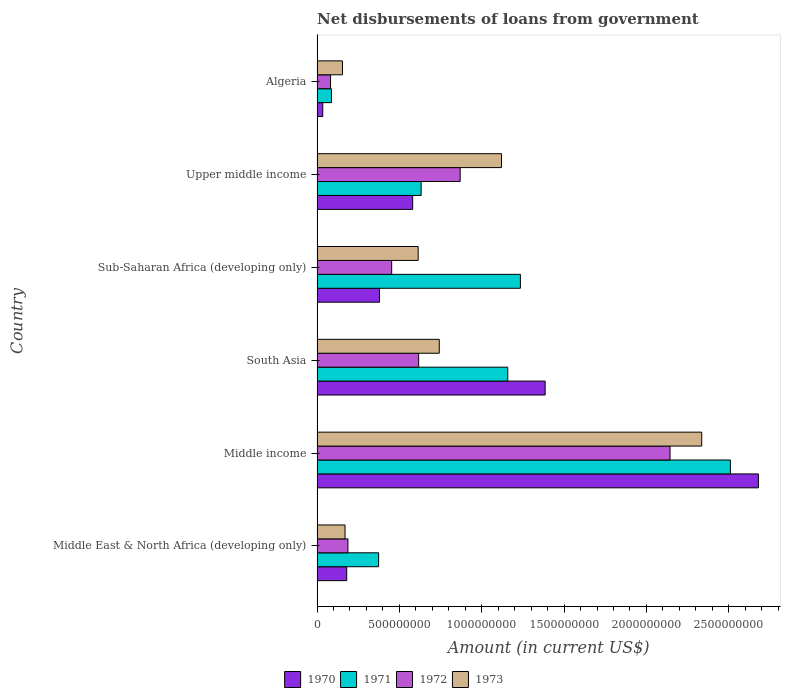How many different coloured bars are there?
Your response must be concise. 4. How many groups of bars are there?
Ensure brevity in your answer.  6. Are the number of bars on each tick of the Y-axis equal?
Your answer should be compact. Yes. How many bars are there on the 4th tick from the top?
Your response must be concise. 4. How many bars are there on the 1st tick from the bottom?
Give a very brief answer. 4. What is the label of the 2nd group of bars from the top?
Your answer should be very brief. Upper middle income. What is the amount of loan disbursed from government in 1973 in Sub-Saharan Africa (developing only)?
Offer a very short reply. 6.14e+08. Across all countries, what is the maximum amount of loan disbursed from government in 1973?
Provide a short and direct response. 2.34e+09. Across all countries, what is the minimum amount of loan disbursed from government in 1970?
Offer a terse response. 3.47e+07. In which country was the amount of loan disbursed from government in 1972 maximum?
Offer a very short reply. Middle income. In which country was the amount of loan disbursed from government in 1973 minimum?
Keep it short and to the point. Algeria. What is the total amount of loan disbursed from government in 1971 in the graph?
Your answer should be compact. 6.00e+09. What is the difference between the amount of loan disbursed from government in 1973 in Sub-Saharan Africa (developing only) and that in Upper middle income?
Offer a very short reply. -5.06e+08. What is the difference between the amount of loan disbursed from government in 1973 in South Asia and the amount of loan disbursed from government in 1970 in Middle East & North Africa (developing only)?
Offer a very short reply. 5.62e+08. What is the average amount of loan disbursed from government in 1973 per country?
Offer a terse response. 8.56e+08. What is the difference between the amount of loan disbursed from government in 1971 and amount of loan disbursed from government in 1970 in Algeria?
Keep it short and to the point. 5.27e+07. What is the ratio of the amount of loan disbursed from government in 1972 in Middle income to that in Sub-Saharan Africa (developing only)?
Make the answer very short. 4.73. Is the difference between the amount of loan disbursed from government in 1971 in Middle income and South Asia greater than the difference between the amount of loan disbursed from government in 1970 in Middle income and South Asia?
Provide a short and direct response. Yes. What is the difference between the highest and the second highest amount of loan disbursed from government in 1972?
Provide a succinct answer. 1.27e+09. What is the difference between the highest and the lowest amount of loan disbursed from government in 1970?
Your answer should be very brief. 2.65e+09. In how many countries, is the amount of loan disbursed from government in 1973 greater than the average amount of loan disbursed from government in 1973 taken over all countries?
Offer a terse response. 2. Is it the case that in every country, the sum of the amount of loan disbursed from government in 1973 and amount of loan disbursed from government in 1971 is greater than the sum of amount of loan disbursed from government in 1970 and amount of loan disbursed from government in 1972?
Provide a short and direct response. No. Is it the case that in every country, the sum of the amount of loan disbursed from government in 1972 and amount of loan disbursed from government in 1971 is greater than the amount of loan disbursed from government in 1973?
Your answer should be very brief. Yes. Are all the bars in the graph horizontal?
Provide a succinct answer. Yes. How many countries are there in the graph?
Offer a terse response. 6. What is the difference between two consecutive major ticks on the X-axis?
Provide a succinct answer. 5.00e+08. Where does the legend appear in the graph?
Give a very brief answer. Bottom center. How are the legend labels stacked?
Provide a short and direct response. Horizontal. What is the title of the graph?
Make the answer very short. Net disbursements of loans from government. What is the Amount (in current US$) of 1970 in Middle East & North Africa (developing only)?
Make the answer very short. 1.80e+08. What is the Amount (in current US$) in 1971 in Middle East & North Africa (developing only)?
Make the answer very short. 3.74e+08. What is the Amount (in current US$) of 1972 in Middle East & North Africa (developing only)?
Offer a terse response. 1.88e+08. What is the Amount (in current US$) of 1973 in Middle East & North Africa (developing only)?
Your answer should be compact. 1.70e+08. What is the Amount (in current US$) in 1970 in Middle income?
Your answer should be compact. 2.68e+09. What is the Amount (in current US$) of 1971 in Middle income?
Your answer should be very brief. 2.51e+09. What is the Amount (in current US$) in 1972 in Middle income?
Your answer should be very brief. 2.14e+09. What is the Amount (in current US$) in 1973 in Middle income?
Provide a succinct answer. 2.34e+09. What is the Amount (in current US$) of 1970 in South Asia?
Give a very brief answer. 1.39e+09. What is the Amount (in current US$) of 1971 in South Asia?
Your response must be concise. 1.16e+09. What is the Amount (in current US$) in 1972 in South Asia?
Your response must be concise. 6.17e+08. What is the Amount (in current US$) of 1973 in South Asia?
Provide a short and direct response. 7.42e+08. What is the Amount (in current US$) of 1970 in Sub-Saharan Africa (developing only)?
Provide a short and direct response. 3.79e+08. What is the Amount (in current US$) in 1971 in Sub-Saharan Africa (developing only)?
Provide a succinct answer. 1.23e+09. What is the Amount (in current US$) in 1972 in Sub-Saharan Africa (developing only)?
Make the answer very short. 4.53e+08. What is the Amount (in current US$) in 1973 in Sub-Saharan Africa (developing only)?
Provide a short and direct response. 6.14e+08. What is the Amount (in current US$) of 1970 in Upper middle income?
Make the answer very short. 5.81e+08. What is the Amount (in current US$) in 1971 in Upper middle income?
Your response must be concise. 6.32e+08. What is the Amount (in current US$) in 1972 in Upper middle income?
Keep it short and to the point. 8.69e+08. What is the Amount (in current US$) in 1973 in Upper middle income?
Provide a succinct answer. 1.12e+09. What is the Amount (in current US$) in 1970 in Algeria?
Provide a succinct answer. 3.47e+07. What is the Amount (in current US$) in 1971 in Algeria?
Ensure brevity in your answer.  8.74e+07. What is the Amount (in current US$) in 1972 in Algeria?
Your answer should be compact. 8.20e+07. What is the Amount (in current US$) in 1973 in Algeria?
Provide a succinct answer. 1.54e+08. Across all countries, what is the maximum Amount (in current US$) of 1970?
Offer a terse response. 2.68e+09. Across all countries, what is the maximum Amount (in current US$) in 1971?
Offer a terse response. 2.51e+09. Across all countries, what is the maximum Amount (in current US$) in 1972?
Offer a very short reply. 2.14e+09. Across all countries, what is the maximum Amount (in current US$) of 1973?
Your answer should be compact. 2.34e+09. Across all countries, what is the minimum Amount (in current US$) in 1970?
Provide a succinct answer. 3.47e+07. Across all countries, what is the minimum Amount (in current US$) in 1971?
Ensure brevity in your answer.  8.74e+07. Across all countries, what is the minimum Amount (in current US$) in 1972?
Offer a terse response. 8.20e+07. Across all countries, what is the minimum Amount (in current US$) in 1973?
Provide a short and direct response. 1.54e+08. What is the total Amount (in current US$) in 1970 in the graph?
Your answer should be compact. 5.24e+09. What is the total Amount (in current US$) in 1971 in the graph?
Give a very brief answer. 6.00e+09. What is the total Amount (in current US$) in 1972 in the graph?
Keep it short and to the point. 4.35e+09. What is the total Amount (in current US$) in 1973 in the graph?
Provide a succinct answer. 5.14e+09. What is the difference between the Amount (in current US$) in 1970 in Middle East & North Africa (developing only) and that in Middle income?
Offer a terse response. -2.50e+09. What is the difference between the Amount (in current US$) of 1971 in Middle East & North Africa (developing only) and that in Middle income?
Your answer should be compact. -2.14e+09. What is the difference between the Amount (in current US$) of 1972 in Middle East & North Africa (developing only) and that in Middle income?
Offer a terse response. -1.96e+09. What is the difference between the Amount (in current US$) of 1973 in Middle East & North Africa (developing only) and that in Middle income?
Ensure brevity in your answer.  -2.17e+09. What is the difference between the Amount (in current US$) of 1970 in Middle East & North Africa (developing only) and that in South Asia?
Provide a succinct answer. -1.20e+09. What is the difference between the Amount (in current US$) in 1971 in Middle East & North Africa (developing only) and that in South Asia?
Ensure brevity in your answer.  -7.84e+08. What is the difference between the Amount (in current US$) in 1972 in Middle East & North Africa (developing only) and that in South Asia?
Ensure brevity in your answer.  -4.29e+08. What is the difference between the Amount (in current US$) of 1973 in Middle East & North Africa (developing only) and that in South Asia?
Your response must be concise. -5.72e+08. What is the difference between the Amount (in current US$) of 1970 in Middle East & North Africa (developing only) and that in Sub-Saharan Africa (developing only)?
Provide a succinct answer. -1.99e+08. What is the difference between the Amount (in current US$) in 1971 in Middle East & North Africa (developing only) and that in Sub-Saharan Africa (developing only)?
Keep it short and to the point. -8.61e+08. What is the difference between the Amount (in current US$) in 1972 in Middle East & North Africa (developing only) and that in Sub-Saharan Africa (developing only)?
Your answer should be compact. -2.66e+08. What is the difference between the Amount (in current US$) in 1973 in Middle East & North Africa (developing only) and that in Sub-Saharan Africa (developing only)?
Offer a very short reply. -4.44e+08. What is the difference between the Amount (in current US$) of 1970 in Middle East & North Africa (developing only) and that in Upper middle income?
Ensure brevity in your answer.  -4.01e+08. What is the difference between the Amount (in current US$) in 1971 in Middle East & North Africa (developing only) and that in Upper middle income?
Ensure brevity in your answer.  -2.58e+08. What is the difference between the Amount (in current US$) in 1972 in Middle East & North Africa (developing only) and that in Upper middle income?
Ensure brevity in your answer.  -6.81e+08. What is the difference between the Amount (in current US$) in 1973 in Middle East & North Africa (developing only) and that in Upper middle income?
Provide a short and direct response. -9.50e+08. What is the difference between the Amount (in current US$) in 1970 in Middle East & North Africa (developing only) and that in Algeria?
Your answer should be very brief. 1.45e+08. What is the difference between the Amount (in current US$) in 1971 in Middle East & North Africa (developing only) and that in Algeria?
Make the answer very short. 2.87e+08. What is the difference between the Amount (in current US$) in 1972 in Middle East & North Africa (developing only) and that in Algeria?
Give a very brief answer. 1.06e+08. What is the difference between the Amount (in current US$) of 1973 in Middle East & North Africa (developing only) and that in Algeria?
Keep it short and to the point. 1.56e+07. What is the difference between the Amount (in current US$) in 1970 in Middle income and that in South Asia?
Offer a very short reply. 1.30e+09. What is the difference between the Amount (in current US$) of 1971 in Middle income and that in South Asia?
Offer a terse response. 1.35e+09. What is the difference between the Amount (in current US$) of 1972 in Middle income and that in South Asia?
Make the answer very short. 1.53e+09. What is the difference between the Amount (in current US$) of 1973 in Middle income and that in South Asia?
Keep it short and to the point. 1.59e+09. What is the difference between the Amount (in current US$) of 1970 in Middle income and that in Sub-Saharan Africa (developing only)?
Offer a very short reply. 2.30e+09. What is the difference between the Amount (in current US$) in 1971 in Middle income and that in Sub-Saharan Africa (developing only)?
Give a very brief answer. 1.28e+09. What is the difference between the Amount (in current US$) in 1972 in Middle income and that in Sub-Saharan Africa (developing only)?
Offer a terse response. 1.69e+09. What is the difference between the Amount (in current US$) in 1973 in Middle income and that in Sub-Saharan Africa (developing only)?
Your answer should be compact. 1.72e+09. What is the difference between the Amount (in current US$) of 1970 in Middle income and that in Upper middle income?
Ensure brevity in your answer.  2.10e+09. What is the difference between the Amount (in current US$) in 1971 in Middle income and that in Upper middle income?
Offer a terse response. 1.88e+09. What is the difference between the Amount (in current US$) in 1972 in Middle income and that in Upper middle income?
Your response must be concise. 1.27e+09. What is the difference between the Amount (in current US$) of 1973 in Middle income and that in Upper middle income?
Your answer should be compact. 1.22e+09. What is the difference between the Amount (in current US$) in 1970 in Middle income and that in Algeria?
Provide a short and direct response. 2.65e+09. What is the difference between the Amount (in current US$) in 1971 in Middle income and that in Algeria?
Provide a short and direct response. 2.42e+09. What is the difference between the Amount (in current US$) of 1972 in Middle income and that in Algeria?
Give a very brief answer. 2.06e+09. What is the difference between the Amount (in current US$) in 1973 in Middle income and that in Algeria?
Keep it short and to the point. 2.18e+09. What is the difference between the Amount (in current US$) in 1970 in South Asia and that in Sub-Saharan Africa (developing only)?
Your response must be concise. 1.01e+09. What is the difference between the Amount (in current US$) in 1971 in South Asia and that in Sub-Saharan Africa (developing only)?
Offer a very short reply. -7.68e+07. What is the difference between the Amount (in current US$) in 1972 in South Asia and that in Sub-Saharan Africa (developing only)?
Keep it short and to the point. 1.64e+08. What is the difference between the Amount (in current US$) in 1973 in South Asia and that in Sub-Saharan Africa (developing only)?
Your answer should be compact. 1.28e+08. What is the difference between the Amount (in current US$) of 1970 in South Asia and that in Upper middle income?
Your response must be concise. 8.04e+08. What is the difference between the Amount (in current US$) in 1971 in South Asia and that in Upper middle income?
Ensure brevity in your answer.  5.26e+08. What is the difference between the Amount (in current US$) in 1972 in South Asia and that in Upper middle income?
Give a very brief answer. -2.52e+08. What is the difference between the Amount (in current US$) in 1973 in South Asia and that in Upper middle income?
Your response must be concise. -3.78e+08. What is the difference between the Amount (in current US$) in 1970 in South Asia and that in Algeria?
Your response must be concise. 1.35e+09. What is the difference between the Amount (in current US$) of 1971 in South Asia and that in Algeria?
Your answer should be compact. 1.07e+09. What is the difference between the Amount (in current US$) of 1972 in South Asia and that in Algeria?
Make the answer very short. 5.35e+08. What is the difference between the Amount (in current US$) in 1973 in South Asia and that in Algeria?
Ensure brevity in your answer.  5.88e+08. What is the difference between the Amount (in current US$) in 1970 in Sub-Saharan Africa (developing only) and that in Upper middle income?
Offer a very short reply. -2.01e+08. What is the difference between the Amount (in current US$) in 1971 in Sub-Saharan Africa (developing only) and that in Upper middle income?
Your response must be concise. 6.03e+08. What is the difference between the Amount (in current US$) of 1972 in Sub-Saharan Africa (developing only) and that in Upper middle income?
Provide a succinct answer. -4.16e+08. What is the difference between the Amount (in current US$) in 1973 in Sub-Saharan Africa (developing only) and that in Upper middle income?
Your answer should be very brief. -5.06e+08. What is the difference between the Amount (in current US$) of 1970 in Sub-Saharan Africa (developing only) and that in Algeria?
Keep it short and to the point. 3.44e+08. What is the difference between the Amount (in current US$) of 1971 in Sub-Saharan Africa (developing only) and that in Algeria?
Ensure brevity in your answer.  1.15e+09. What is the difference between the Amount (in current US$) of 1972 in Sub-Saharan Africa (developing only) and that in Algeria?
Give a very brief answer. 3.71e+08. What is the difference between the Amount (in current US$) in 1973 in Sub-Saharan Africa (developing only) and that in Algeria?
Make the answer very short. 4.60e+08. What is the difference between the Amount (in current US$) of 1970 in Upper middle income and that in Algeria?
Ensure brevity in your answer.  5.46e+08. What is the difference between the Amount (in current US$) of 1971 in Upper middle income and that in Algeria?
Your response must be concise. 5.45e+08. What is the difference between the Amount (in current US$) in 1972 in Upper middle income and that in Algeria?
Offer a very short reply. 7.87e+08. What is the difference between the Amount (in current US$) in 1973 in Upper middle income and that in Algeria?
Keep it short and to the point. 9.66e+08. What is the difference between the Amount (in current US$) of 1970 in Middle East & North Africa (developing only) and the Amount (in current US$) of 1971 in Middle income?
Provide a succinct answer. -2.33e+09. What is the difference between the Amount (in current US$) of 1970 in Middle East & North Africa (developing only) and the Amount (in current US$) of 1972 in Middle income?
Provide a succinct answer. -1.96e+09. What is the difference between the Amount (in current US$) in 1970 in Middle East & North Africa (developing only) and the Amount (in current US$) in 1973 in Middle income?
Your answer should be compact. -2.16e+09. What is the difference between the Amount (in current US$) of 1971 in Middle East & North Africa (developing only) and the Amount (in current US$) of 1972 in Middle income?
Give a very brief answer. -1.77e+09. What is the difference between the Amount (in current US$) in 1971 in Middle East & North Africa (developing only) and the Amount (in current US$) in 1973 in Middle income?
Keep it short and to the point. -1.96e+09. What is the difference between the Amount (in current US$) of 1972 in Middle East & North Africa (developing only) and the Amount (in current US$) of 1973 in Middle income?
Provide a short and direct response. -2.15e+09. What is the difference between the Amount (in current US$) of 1970 in Middle East & North Africa (developing only) and the Amount (in current US$) of 1971 in South Asia?
Your answer should be compact. -9.78e+08. What is the difference between the Amount (in current US$) in 1970 in Middle East & North Africa (developing only) and the Amount (in current US$) in 1972 in South Asia?
Your answer should be very brief. -4.37e+08. What is the difference between the Amount (in current US$) in 1970 in Middle East & North Africa (developing only) and the Amount (in current US$) in 1973 in South Asia?
Provide a succinct answer. -5.62e+08. What is the difference between the Amount (in current US$) of 1971 in Middle East & North Africa (developing only) and the Amount (in current US$) of 1972 in South Asia?
Provide a succinct answer. -2.43e+08. What is the difference between the Amount (in current US$) of 1971 in Middle East & North Africa (developing only) and the Amount (in current US$) of 1973 in South Asia?
Your response must be concise. -3.68e+08. What is the difference between the Amount (in current US$) in 1972 in Middle East & North Africa (developing only) and the Amount (in current US$) in 1973 in South Asia?
Your response must be concise. -5.55e+08. What is the difference between the Amount (in current US$) in 1970 in Middle East & North Africa (developing only) and the Amount (in current US$) in 1971 in Sub-Saharan Africa (developing only)?
Your answer should be very brief. -1.05e+09. What is the difference between the Amount (in current US$) in 1970 in Middle East & North Africa (developing only) and the Amount (in current US$) in 1972 in Sub-Saharan Africa (developing only)?
Your answer should be compact. -2.73e+08. What is the difference between the Amount (in current US$) in 1970 in Middle East & North Africa (developing only) and the Amount (in current US$) in 1973 in Sub-Saharan Africa (developing only)?
Offer a very short reply. -4.34e+08. What is the difference between the Amount (in current US$) of 1971 in Middle East & North Africa (developing only) and the Amount (in current US$) of 1972 in Sub-Saharan Africa (developing only)?
Provide a short and direct response. -7.92e+07. What is the difference between the Amount (in current US$) of 1971 in Middle East & North Africa (developing only) and the Amount (in current US$) of 1973 in Sub-Saharan Africa (developing only)?
Your answer should be compact. -2.40e+08. What is the difference between the Amount (in current US$) of 1972 in Middle East & North Africa (developing only) and the Amount (in current US$) of 1973 in Sub-Saharan Africa (developing only)?
Your response must be concise. -4.27e+08. What is the difference between the Amount (in current US$) of 1970 in Middle East & North Africa (developing only) and the Amount (in current US$) of 1971 in Upper middle income?
Your answer should be compact. -4.52e+08. What is the difference between the Amount (in current US$) in 1970 in Middle East & North Africa (developing only) and the Amount (in current US$) in 1972 in Upper middle income?
Your answer should be very brief. -6.89e+08. What is the difference between the Amount (in current US$) of 1970 in Middle East & North Africa (developing only) and the Amount (in current US$) of 1973 in Upper middle income?
Provide a succinct answer. -9.40e+08. What is the difference between the Amount (in current US$) in 1971 in Middle East & North Africa (developing only) and the Amount (in current US$) in 1972 in Upper middle income?
Your answer should be very brief. -4.95e+08. What is the difference between the Amount (in current US$) in 1971 in Middle East & North Africa (developing only) and the Amount (in current US$) in 1973 in Upper middle income?
Ensure brevity in your answer.  -7.46e+08. What is the difference between the Amount (in current US$) of 1972 in Middle East & North Africa (developing only) and the Amount (in current US$) of 1973 in Upper middle income?
Give a very brief answer. -9.32e+08. What is the difference between the Amount (in current US$) in 1970 in Middle East & North Africa (developing only) and the Amount (in current US$) in 1971 in Algeria?
Your answer should be very brief. 9.27e+07. What is the difference between the Amount (in current US$) of 1970 in Middle East & North Africa (developing only) and the Amount (in current US$) of 1972 in Algeria?
Give a very brief answer. 9.81e+07. What is the difference between the Amount (in current US$) in 1970 in Middle East & North Africa (developing only) and the Amount (in current US$) in 1973 in Algeria?
Make the answer very short. 2.58e+07. What is the difference between the Amount (in current US$) in 1971 in Middle East & North Africa (developing only) and the Amount (in current US$) in 1972 in Algeria?
Make the answer very short. 2.92e+08. What is the difference between the Amount (in current US$) of 1971 in Middle East & North Africa (developing only) and the Amount (in current US$) of 1973 in Algeria?
Provide a short and direct response. 2.20e+08. What is the difference between the Amount (in current US$) of 1972 in Middle East & North Africa (developing only) and the Amount (in current US$) of 1973 in Algeria?
Provide a succinct answer. 3.33e+07. What is the difference between the Amount (in current US$) of 1970 in Middle income and the Amount (in current US$) of 1971 in South Asia?
Offer a very short reply. 1.52e+09. What is the difference between the Amount (in current US$) in 1970 in Middle income and the Amount (in current US$) in 1972 in South Asia?
Provide a short and direct response. 2.06e+09. What is the difference between the Amount (in current US$) in 1970 in Middle income and the Amount (in current US$) in 1973 in South Asia?
Ensure brevity in your answer.  1.94e+09. What is the difference between the Amount (in current US$) of 1971 in Middle income and the Amount (in current US$) of 1972 in South Asia?
Ensure brevity in your answer.  1.89e+09. What is the difference between the Amount (in current US$) of 1971 in Middle income and the Amount (in current US$) of 1973 in South Asia?
Your answer should be very brief. 1.77e+09. What is the difference between the Amount (in current US$) in 1972 in Middle income and the Amount (in current US$) in 1973 in South Asia?
Make the answer very short. 1.40e+09. What is the difference between the Amount (in current US$) in 1970 in Middle income and the Amount (in current US$) in 1971 in Sub-Saharan Africa (developing only)?
Keep it short and to the point. 1.45e+09. What is the difference between the Amount (in current US$) in 1970 in Middle income and the Amount (in current US$) in 1972 in Sub-Saharan Africa (developing only)?
Your answer should be compact. 2.23e+09. What is the difference between the Amount (in current US$) of 1970 in Middle income and the Amount (in current US$) of 1973 in Sub-Saharan Africa (developing only)?
Offer a terse response. 2.07e+09. What is the difference between the Amount (in current US$) of 1971 in Middle income and the Amount (in current US$) of 1972 in Sub-Saharan Africa (developing only)?
Provide a succinct answer. 2.06e+09. What is the difference between the Amount (in current US$) of 1971 in Middle income and the Amount (in current US$) of 1973 in Sub-Saharan Africa (developing only)?
Offer a very short reply. 1.90e+09. What is the difference between the Amount (in current US$) in 1972 in Middle income and the Amount (in current US$) in 1973 in Sub-Saharan Africa (developing only)?
Keep it short and to the point. 1.53e+09. What is the difference between the Amount (in current US$) of 1970 in Middle income and the Amount (in current US$) of 1971 in Upper middle income?
Your answer should be very brief. 2.05e+09. What is the difference between the Amount (in current US$) in 1970 in Middle income and the Amount (in current US$) in 1972 in Upper middle income?
Offer a very short reply. 1.81e+09. What is the difference between the Amount (in current US$) in 1970 in Middle income and the Amount (in current US$) in 1973 in Upper middle income?
Offer a very short reply. 1.56e+09. What is the difference between the Amount (in current US$) in 1971 in Middle income and the Amount (in current US$) in 1972 in Upper middle income?
Make the answer very short. 1.64e+09. What is the difference between the Amount (in current US$) of 1971 in Middle income and the Amount (in current US$) of 1973 in Upper middle income?
Ensure brevity in your answer.  1.39e+09. What is the difference between the Amount (in current US$) in 1972 in Middle income and the Amount (in current US$) in 1973 in Upper middle income?
Give a very brief answer. 1.02e+09. What is the difference between the Amount (in current US$) in 1970 in Middle income and the Amount (in current US$) in 1971 in Algeria?
Provide a succinct answer. 2.59e+09. What is the difference between the Amount (in current US$) of 1970 in Middle income and the Amount (in current US$) of 1972 in Algeria?
Your answer should be compact. 2.60e+09. What is the difference between the Amount (in current US$) of 1970 in Middle income and the Amount (in current US$) of 1973 in Algeria?
Your response must be concise. 2.53e+09. What is the difference between the Amount (in current US$) in 1971 in Middle income and the Amount (in current US$) in 1972 in Algeria?
Offer a terse response. 2.43e+09. What is the difference between the Amount (in current US$) in 1971 in Middle income and the Amount (in current US$) in 1973 in Algeria?
Give a very brief answer. 2.36e+09. What is the difference between the Amount (in current US$) of 1972 in Middle income and the Amount (in current US$) of 1973 in Algeria?
Your response must be concise. 1.99e+09. What is the difference between the Amount (in current US$) of 1970 in South Asia and the Amount (in current US$) of 1971 in Sub-Saharan Africa (developing only)?
Keep it short and to the point. 1.50e+08. What is the difference between the Amount (in current US$) in 1970 in South Asia and the Amount (in current US$) in 1972 in Sub-Saharan Africa (developing only)?
Ensure brevity in your answer.  9.32e+08. What is the difference between the Amount (in current US$) of 1970 in South Asia and the Amount (in current US$) of 1973 in Sub-Saharan Africa (developing only)?
Make the answer very short. 7.71e+08. What is the difference between the Amount (in current US$) of 1971 in South Asia and the Amount (in current US$) of 1972 in Sub-Saharan Africa (developing only)?
Give a very brief answer. 7.05e+08. What is the difference between the Amount (in current US$) of 1971 in South Asia and the Amount (in current US$) of 1973 in Sub-Saharan Africa (developing only)?
Offer a terse response. 5.44e+08. What is the difference between the Amount (in current US$) in 1972 in South Asia and the Amount (in current US$) in 1973 in Sub-Saharan Africa (developing only)?
Provide a short and direct response. 2.74e+06. What is the difference between the Amount (in current US$) in 1970 in South Asia and the Amount (in current US$) in 1971 in Upper middle income?
Provide a succinct answer. 7.53e+08. What is the difference between the Amount (in current US$) in 1970 in South Asia and the Amount (in current US$) in 1972 in Upper middle income?
Your answer should be very brief. 5.16e+08. What is the difference between the Amount (in current US$) in 1970 in South Asia and the Amount (in current US$) in 1973 in Upper middle income?
Offer a very short reply. 2.65e+08. What is the difference between the Amount (in current US$) in 1971 in South Asia and the Amount (in current US$) in 1972 in Upper middle income?
Give a very brief answer. 2.89e+08. What is the difference between the Amount (in current US$) of 1971 in South Asia and the Amount (in current US$) of 1973 in Upper middle income?
Your response must be concise. 3.80e+07. What is the difference between the Amount (in current US$) of 1972 in South Asia and the Amount (in current US$) of 1973 in Upper middle income?
Offer a very short reply. -5.03e+08. What is the difference between the Amount (in current US$) in 1970 in South Asia and the Amount (in current US$) in 1971 in Algeria?
Make the answer very short. 1.30e+09. What is the difference between the Amount (in current US$) of 1970 in South Asia and the Amount (in current US$) of 1972 in Algeria?
Keep it short and to the point. 1.30e+09. What is the difference between the Amount (in current US$) in 1970 in South Asia and the Amount (in current US$) in 1973 in Algeria?
Your response must be concise. 1.23e+09. What is the difference between the Amount (in current US$) of 1971 in South Asia and the Amount (in current US$) of 1972 in Algeria?
Provide a succinct answer. 1.08e+09. What is the difference between the Amount (in current US$) of 1971 in South Asia and the Amount (in current US$) of 1973 in Algeria?
Offer a terse response. 1.00e+09. What is the difference between the Amount (in current US$) of 1972 in South Asia and the Amount (in current US$) of 1973 in Algeria?
Your response must be concise. 4.63e+08. What is the difference between the Amount (in current US$) of 1970 in Sub-Saharan Africa (developing only) and the Amount (in current US$) of 1971 in Upper middle income?
Make the answer very short. -2.53e+08. What is the difference between the Amount (in current US$) of 1970 in Sub-Saharan Africa (developing only) and the Amount (in current US$) of 1972 in Upper middle income?
Provide a short and direct response. -4.90e+08. What is the difference between the Amount (in current US$) of 1970 in Sub-Saharan Africa (developing only) and the Amount (in current US$) of 1973 in Upper middle income?
Keep it short and to the point. -7.41e+08. What is the difference between the Amount (in current US$) in 1971 in Sub-Saharan Africa (developing only) and the Amount (in current US$) in 1972 in Upper middle income?
Give a very brief answer. 3.66e+08. What is the difference between the Amount (in current US$) of 1971 in Sub-Saharan Africa (developing only) and the Amount (in current US$) of 1973 in Upper middle income?
Make the answer very short. 1.15e+08. What is the difference between the Amount (in current US$) of 1972 in Sub-Saharan Africa (developing only) and the Amount (in current US$) of 1973 in Upper middle income?
Give a very brief answer. -6.67e+08. What is the difference between the Amount (in current US$) in 1970 in Sub-Saharan Africa (developing only) and the Amount (in current US$) in 1971 in Algeria?
Make the answer very short. 2.92e+08. What is the difference between the Amount (in current US$) of 1970 in Sub-Saharan Africa (developing only) and the Amount (in current US$) of 1972 in Algeria?
Your answer should be very brief. 2.97e+08. What is the difference between the Amount (in current US$) of 1970 in Sub-Saharan Africa (developing only) and the Amount (in current US$) of 1973 in Algeria?
Provide a short and direct response. 2.25e+08. What is the difference between the Amount (in current US$) in 1971 in Sub-Saharan Africa (developing only) and the Amount (in current US$) in 1972 in Algeria?
Make the answer very short. 1.15e+09. What is the difference between the Amount (in current US$) of 1971 in Sub-Saharan Africa (developing only) and the Amount (in current US$) of 1973 in Algeria?
Give a very brief answer. 1.08e+09. What is the difference between the Amount (in current US$) in 1972 in Sub-Saharan Africa (developing only) and the Amount (in current US$) in 1973 in Algeria?
Offer a very short reply. 2.99e+08. What is the difference between the Amount (in current US$) in 1970 in Upper middle income and the Amount (in current US$) in 1971 in Algeria?
Your response must be concise. 4.93e+08. What is the difference between the Amount (in current US$) in 1970 in Upper middle income and the Amount (in current US$) in 1972 in Algeria?
Your response must be concise. 4.99e+08. What is the difference between the Amount (in current US$) of 1970 in Upper middle income and the Amount (in current US$) of 1973 in Algeria?
Your answer should be compact. 4.26e+08. What is the difference between the Amount (in current US$) of 1971 in Upper middle income and the Amount (in current US$) of 1972 in Algeria?
Your answer should be very brief. 5.50e+08. What is the difference between the Amount (in current US$) of 1971 in Upper middle income and the Amount (in current US$) of 1973 in Algeria?
Provide a succinct answer. 4.78e+08. What is the difference between the Amount (in current US$) of 1972 in Upper middle income and the Amount (in current US$) of 1973 in Algeria?
Provide a succinct answer. 7.15e+08. What is the average Amount (in current US$) in 1970 per country?
Ensure brevity in your answer.  8.73e+08. What is the average Amount (in current US$) of 1971 per country?
Provide a succinct answer. 9.99e+08. What is the average Amount (in current US$) in 1972 per country?
Ensure brevity in your answer.  7.25e+08. What is the average Amount (in current US$) in 1973 per country?
Keep it short and to the point. 8.56e+08. What is the difference between the Amount (in current US$) of 1970 and Amount (in current US$) of 1971 in Middle East & North Africa (developing only)?
Your answer should be compact. -1.94e+08. What is the difference between the Amount (in current US$) of 1970 and Amount (in current US$) of 1972 in Middle East & North Africa (developing only)?
Your response must be concise. -7.47e+06. What is the difference between the Amount (in current US$) in 1970 and Amount (in current US$) in 1973 in Middle East & North Africa (developing only)?
Your response must be concise. 1.02e+07. What is the difference between the Amount (in current US$) of 1971 and Amount (in current US$) of 1972 in Middle East & North Africa (developing only)?
Offer a terse response. 1.86e+08. What is the difference between the Amount (in current US$) of 1971 and Amount (in current US$) of 1973 in Middle East & North Africa (developing only)?
Your response must be concise. 2.04e+08. What is the difference between the Amount (in current US$) of 1972 and Amount (in current US$) of 1973 in Middle East & North Africa (developing only)?
Your answer should be compact. 1.77e+07. What is the difference between the Amount (in current US$) of 1970 and Amount (in current US$) of 1971 in Middle income?
Give a very brief answer. 1.70e+08. What is the difference between the Amount (in current US$) of 1970 and Amount (in current US$) of 1972 in Middle income?
Offer a very short reply. 5.37e+08. What is the difference between the Amount (in current US$) in 1970 and Amount (in current US$) in 1973 in Middle income?
Give a very brief answer. 3.44e+08. What is the difference between the Amount (in current US$) of 1971 and Amount (in current US$) of 1972 in Middle income?
Keep it short and to the point. 3.67e+08. What is the difference between the Amount (in current US$) of 1971 and Amount (in current US$) of 1973 in Middle income?
Give a very brief answer. 1.74e+08. What is the difference between the Amount (in current US$) in 1972 and Amount (in current US$) in 1973 in Middle income?
Your answer should be very brief. -1.92e+08. What is the difference between the Amount (in current US$) in 1970 and Amount (in current US$) in 1971 in South Asia?
Your answer should be compact. 2.27e+08. What is the difference between the Amount (in current US$) in 1970 and Amount (in current US$) in 1972 in South Asia?
Provide a succinct answer. 7.68e+08. What is the difference between the Amount (in current US$) in 1970 and Amount (in current US$) in 1973 in South Asia?
Provide a succinct answer. 6.43e+08. What is the difference between the Amount (in current US$) of 1971 and Amount (in current US$) of 1972 in South Asia?
Make the answer very short. 5.41e+08. What is the difference between the Amount (in current US$) of 1971 and Amount (in current US$) of 1973 in South Asia?
Your answer should be compact. 4.16e+08. What is the difference between the Amount (in current US$) of 1972 and Amount (in current US$) of 1973 in South Asia?
Provide a short and direct response. -1.25e+08. What is the difference between the Amount (in current US$) of 1970 and Amount (in current US$) of 1971 in Sub-Saharan Africa (developing only)?
Provide a short and direct response. -8.56e+08. What is the difference between the Amount (in current US$) in 1970 and Amount (in current US$) in 1972 in Sub-Saharan Africa (developing only)?
Your answer should be compact. -7.40e+07. What is the difference between the Amount (in current US$) in 1970 and Amount (in current US$) in 1973 in Sub-Saharan Africa (developing only)?
Offer a very short reply. -2.35e+08. What is the difference between the Amount (in current US$) of 1971 and Amount (in current US$) of 1972 in Sub-Saharan Africa (developing only)?
Ensure brevity in your answer.  7.82e+08. What is the difference between the Amount (in current US$) of 1971 and Amount (in current US$) of 1973 in Sub-Saharan Africa (developing only)?
Offer a very short reply. 6.21e+08. What is the difference between the Amount (in current US$) of 1972 and Amount (in current US$) of 1973 in Sub-Saharan Africa (developing only)?
Make the answer very short. -1.61e+08. What is the difference between the Amount (in current US$) in 1970 and Amount (in current US$) in 1971 in Upper middle income?
Make the answer very short. -5.14e+07. What is the difference between the Amount (in current US$) in 1970 and Amount (in current US$) in 1972 in Upper middle income?
Offer a terse response. -2.88e+08. What is the difference between the Amount (in current US$) in 1970 and Amount (in current US$) in 1973 in Upper middle income?
Provide a short and direct response. -5.39e+08. What is the difference between the Amount (in current US$) of 1971 and Amount (in current US$) of 1972 in Upper middle income?
Offer a terse response. -2.37e+08. What is the difference between the Amount (in current US$) in 1971 and Amount (in current US$) in 1973 in Upper middle income?
Your response must be concise. -4.88e+08. What is the difference between the Amount (in current US$) in 1972 and Amount (in current US$) in 1973 in Upper middle income?
Your response must be concise. -2.51e+08. What is the difference between the Amount (in current US$) in 1970 and Amount (in current US$) in 1971 in Algeria?
Give a very brief answer. -5.27e+07. What is the difference between the Amount (in current US$) in 1970 and Amount (in current US$) in 1972 in Algeria?
Provide a short and direct response. -4.73e+07. What is the difference between the Amount (in current US$) of 1970 and Amount (in current US$) of 1973 in Algeria?
Your answer should be very brief. -1.20e+08. What is the difference between the Amount (in current US$) of 1971 and Amount (in current US$) of 1972 in Algeria?
Ensure brevity in your answer.  5.44e+06. What is the difference between the Amount (in current US$) in 1971 and Amount (in current US$) in 1973 in Algeria?
Provide a short and direct response. -6.69e+07. What is the difference between the Amount (in current US$) in 1972 and Amount (in current US$) in 1973 in Algeria?
Make the answer very short. -7.23e+07. What is the ratio of the Amount (in current US$) in 1970 in Middle East & North Africa (developing only) to that in Middle income?
Offer a very short reply. 0.07. What is the ratio of the Amount (in current US$) of 1971 in Middle East & North Africa (developing only) to that in Middle income?
Your answer should be compact. 0.15. What is the ratio of the Amount (in current US$) in 1972 in Middle East & North Africa (developing only) to that in Middle income?
Offer a terse response. 0.09. What is the ratio of the Amount (in current US$) of 1973 in Middle East & North Africa (developing only) to that in Middle income?
Offer a terse response. 0.07. What is the ratio of the Amount (in current US$) of 1970 in Middle East & North Africa (developing only) to that in South Asia?
Offer a terse response. 0.13. What is the ratio of the Amount (in current US$) of 1971 in Middle East & North Africa (developing only) to that in South Asia?
Offer a very short reply. 0.32. What is the ratio of the Amount (in current US$) of 1972 in Middle East & North Africa (developing only) to that in South Asia?
Your answer should be very brief. 0.3. What is the ratio of the Amount (in current US$) of 1973 in Middle East & North Africa (developing only) to that in South Asia?
Provide a short and direct response. 0.23. What is the ratio of the Amount (in current US$) in 1970 in Middle East & North Africa (developing only) to that in Sub-Saharan Africa (developing only)?
Give a very brief answer. 0.47. What is the ratio of the Amount (in current US$) of 1971 in Middle East & North Africa (developing only) to that in Sub-Saharan Africa (developing only)?
Offer a very short reply. 0.3. What is the ratio of the Amount (in current US$) in 1972 in Middle East & North Africa (developing only) to that in Sub-Saharan Africa (developing only)?
Offer a very short reply. 0.41. What is the ratio of the Amount (in current US$) of 1973 in Middle East & North Africa (developing only) to that in Sub-Saharan Africa (developing only)?
Make the answer very short. 0.28. What is the ratio of the Amount (in current US$) of 1970 in Middle East & North Africa (developing only) to that in Upper middle income?
Offer a terse response. 0.31. What is the ratio of the Amount (in current US$) of 1971 in Middle East & North Africa (developing only) to that in Upper middle income?
Keep it short and to the point. 0.59. What is the ratio of the Amount (in current US$) in 1972 in Middle East & North Africa (developing only) to that in Upper middle income?
Offer a very short reply. 0.22. What is the ratio of the Amount (in current US$) of 1973 in Middle East & North Africa (developing only) to that in Upper middle income?
Your answer should be very brief. 0.15. What is the ratio of the Amount (in current US$) of 1970 in Middle East & North Africa (developing only) to that in Algeria?
Give a very brief answer. 5.19. What is the ratio of the Amount (in current US$) of 1971 in Middle East & North Africa (developing only) to that in Algeria?
Your answer should be compact. 4.28. What is the ratio of the Amount (in current US$) in 1972 in Middle East & North Africa (developing only) to that in Algeria?
Offer a very short reply. 2.29. What is the ratio of the Amount (in current US$) of 1973 in Middle East & North Africa (developing only) to that in Algeria?
Your answer should be very brief. 1.1. What is the ratio of the Amount (in current US$) of 1970 in Middle income to that in South Asia?
Your answer should be compact. 1.94. What is the ratio of the Amount (in current US$) of 1971 in Middle income to that in South Asia?
Offer a terse response. 2.17. What is the ratio of the Amount (in current US$) in 1972 in Middle income to that in South Asia?
Provide a short and direct response. 3.47. What is the ratio of the Amount (in current US$) of 1973 in Middle income to that in South Asia?
Give a very brief answer. 3.15. What is the ratio of the Amount (in current US$) in 1970 in Middle income to that in Sub-Saharan Africa (developing only)?
Your response must be concise. 7.07. What is the ratio of the Amount (in current US$) of 1971 in Middle income to that in Sub-Saharan Africa (developing only)?
Your answer should be compact. 2.03. What is the ratio of the Amount (in current US$) of 1972 in Middle income to that in Sub-Saharan Africa (developing only)?
Your response must be concise. 4.73. What is the ratio of the Amount (in current US$) in 1973 in Middle income to that in Sub-Saharan Africa (developing only)?
Offer a very short reply. 3.8. What is the ratio of the Amount (in current US$) of 1970 in Middle income to that in Upper middle income?
Provide a short and direct response. 4.62. What is the ratio of the Amount (in current US$) of 1971 in Middle income to that in Upper middle income?
Your answer should be very brief. 3.97. What is the ratio of the Amount (in current US$) of 1972 in Middle income to that in Upper middle income?
Give a very brief answer. 2.47. What is the ratio of the Amount (in current US$) of 1973 in Middle income to that in Upper middle income?
Offer a very short reply. 2.09. What is the ratio of the Amount (in current US$) of 1970 in Middle income to that in Algeria?
Make the answer very short. 77.22. What is the ratio of the Amount (in current US$) in 1971 in Middle income to that in Algeria?
Provide a succinct answer. 28.71. What is the ratio of the Amount (in current US$) in 1972 in Middle income to that in Algeria?
Give a very brief answer. 26.14. What is the ratio of the Amount (in current US$) in 1973 in Middle income to that in Algeria?
Offer a terse response. 15.14. What is the ratio of the Amount (in current US$) of 1970 in South Asia to that in Sub-Saharan Africa (developing only)?
Provide a succinct answer. 3.65. What is the ratio of the Amount (in current US$) of 1971 in South Asia to that in Sub-Saharan Africa (developing only)?
Your answer should be very brief. 0.94. What is the ratio of the Amount (in current US$) in 1972 in South Asia to that in Sub-Saharan Africa (developing only)?
Provide a short and direct response. 1.36. What is the ratio of the Amount (in current US$) of 1973 in South Asia to that in Sub-Saharan Africa (developing only)?
Offer a terse response. 1.21. What is the ratio of the Amount (in current US$) of 1970 in South Asia to that in Upper middle income?
Ensure brevity in your answer.  2.39. What is the ratio of the Amount (in current US$) of 1971 in South Asia to that in Upper middle income?
Offer a terse response. 1.83. What is the ratio of the Amount (in current US$) in 1972 in South Asia to that in Upper middle income?
Ensure brevity in your answer.  0.71. What is the ratio of the Amount (in current US$) in 1973 in South Asia to that in Upper middle income?
Your answer should be very brief. 0.66. What is the ratio of the Amount (in current US$) in 1970 in South Asia to that in Algeria?
Give a very brief answer. 39.9. What is the ratio of the Amount (in current US$) of 1971 in South Asia to that in Algeria?
Make the answer very short. 13.25. What is the ratio of the Amount (in current US$) in 1972 in South Asia to that in Algeria?
Your answer should be very brief. 7.52. What is the ratio of the Amount (in current US$) of 1973 in South Asia to that in Algeria?
Ensure brevity in your answer.  4.81. What is the ratio of the Amount (in current US$) in 1970 in Sub-Saharan Africa (developing only) to that in Upper middle income?
Ensure brevity in your answer.  0.65. What is the ratio of the Amount (in current US$) of 1971 in Sub-Saharan Africa (developing only) to that in Upper middle income?
Provide a short and direct response. 1.95. What is the ratio of the Amount (in current US$) in 1972 in Sub-Saharan Africa (developing only) to that in Upper middle income?
Provide a succinct answer. 0.52. What is the ratio of the Amount (in current US$) of 1973 in Sub-Saharan Africa (developing only) to that in Upper middle income?
Keep it short and to the point. 0.55. What is the ratio of the Amount (in current US$) of 1970 in Sub-Saharan Africa (developing only) to that in Algeria?
Your answer should be compact. 10.92. What is the ratio of the Amount (in current US$) in 1971 in Sub-Saharan Africa (developing only) to that in Algeria?
Offer a very short reply. 14.12. What is the ratio of the Amount (in current US$) in 1972 in Sub-Saharan Africa (developing only) to that in Algeria?
Keep it short and to the point. 5.53. What is the ratio of the Amount (in current US$) of 1973 in Sub-Saharan Africa (developing only) to that in Algeria?
Your response must be concise. 3.98. What is the ratio of the Amount (in current US$) of 1970 in Upper middle income to that in Algeria?
Offer a terse response. 16.73. What is the ratio of the Amount (in current US$) in 1971 in Upper middle income to that in Algeria?
Keep it short and to the point. 7.23. What is the ratio of the Amount (in current US$) in 1972 in Upper middle income to that in Algeria?
Ensure brevity in your answer.  10.6. What is the ratio of the Amount (in current US$) of 1973 in Upper middle income to that in Algeria?
Offer a terse response. 7.26. What is the difference between the highest and the second highest Amount (in current US$) of 1970?
Your answer should be very brief. 1.30e+09. What is the difference between the highest and the second highest Amount (in current US$) of 1971?
Offer a very short reply. 1.28e+09. What is the difference between the highest and the second highest Amount (in current US$) in 1972?
Your answer should be very brief. 1.27e+09. What is the difference between the highest and the second highest Amount (in current US$) of 1973?
Your answer should be compact. 1.22e+09. What is the difference between the highest and the lowest Amount (in current US$) in 1970?
Your answer should be compact. 2.65e+09. What is the difference between the highest and the lowest Amount (in current US$) in 1971?
Make the answer very short. 2.42e+09. What is the difference between the highest and the lowest Amount (in current US$) in 1972?
Offer a terse response. 2.06e+09. What is the difference between the highest and the lowest Amount (in current US$) of 1973?
Give a very brief answer. 2.18e+09. 